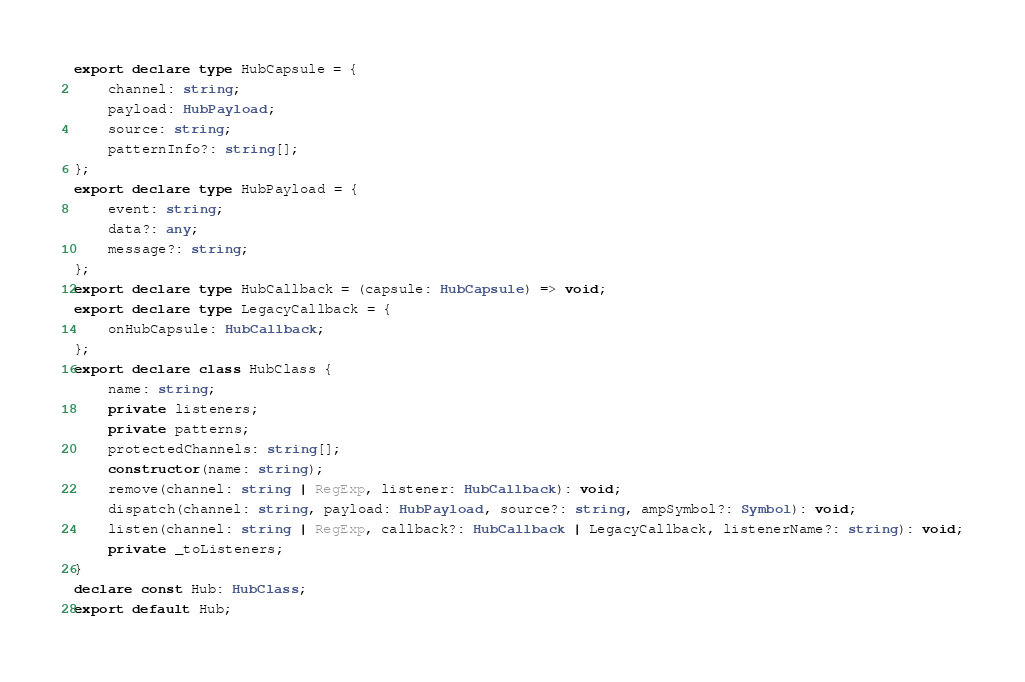<code> <loc_0><loc_0><loc_500><loc_500><_TypeScript_>export declare type HubCapsule = {
    channel: string;
    payload: HubPayload;
    source: string;
    patternInfo?: string[];
};
export declare type HubPayload = {
    event: string;
    data?: any;
    message?: string;
};
export declare type HubCallback = (capsule: HubCapsule) => void;
export declare type LegacyCallback = {
    onHubCapsule: HubCallback;
};
export declare class HubClass {
    name: string;
    private listeners;
    private patterns;
    protectedChannels: string[];
    constructor(name: string);
    remove(channel: string | RegExp, listener: HubCallback): void;
    dispatch(channel: string, payload: HubPayload, source?: string, ampSymbol?: Symbol): void;
    listen(channel: string | RegExp, callback?: HubCallback | LegacyCallback, listenerName?: string): void;
    private _toListeners;
}
declare const Hub: HubClass;
export default Hub;
</code> 